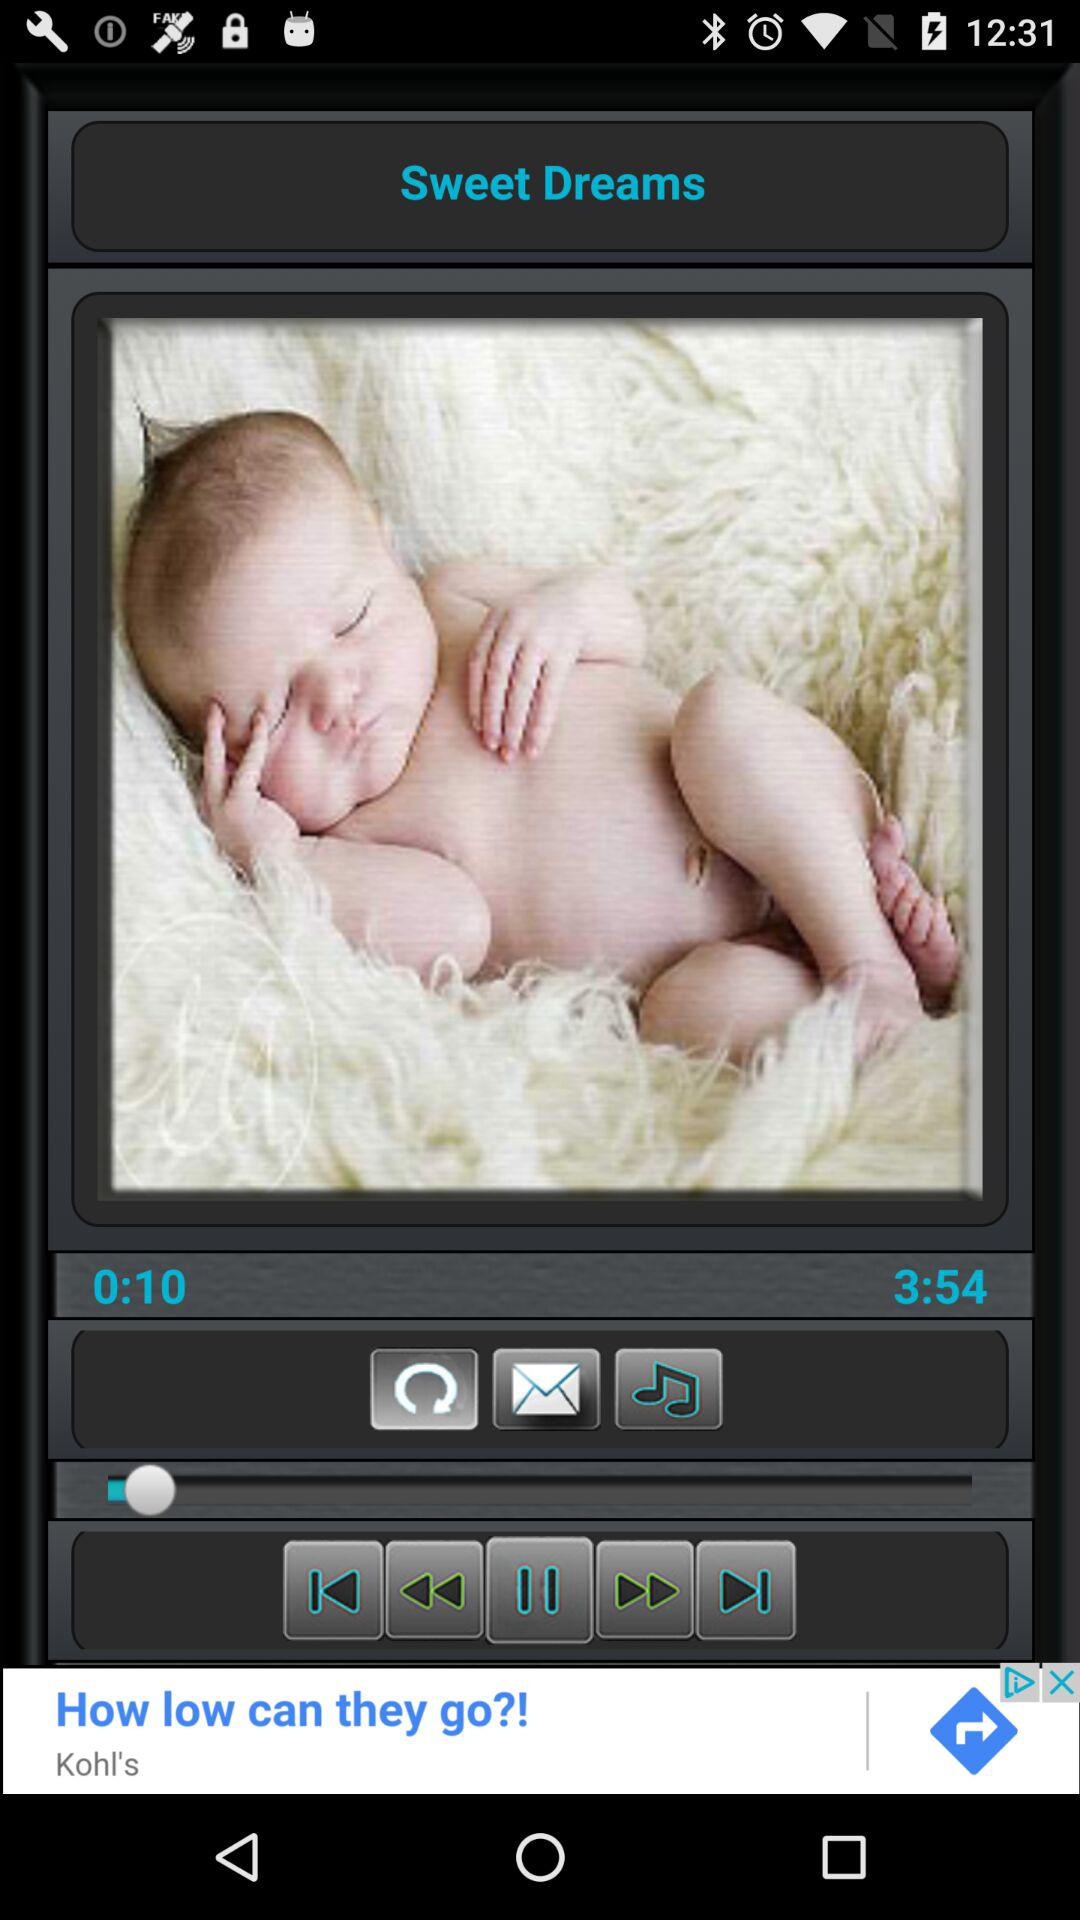What is the length of the song? The length of the song is 3 minutes and 54 seconds. 